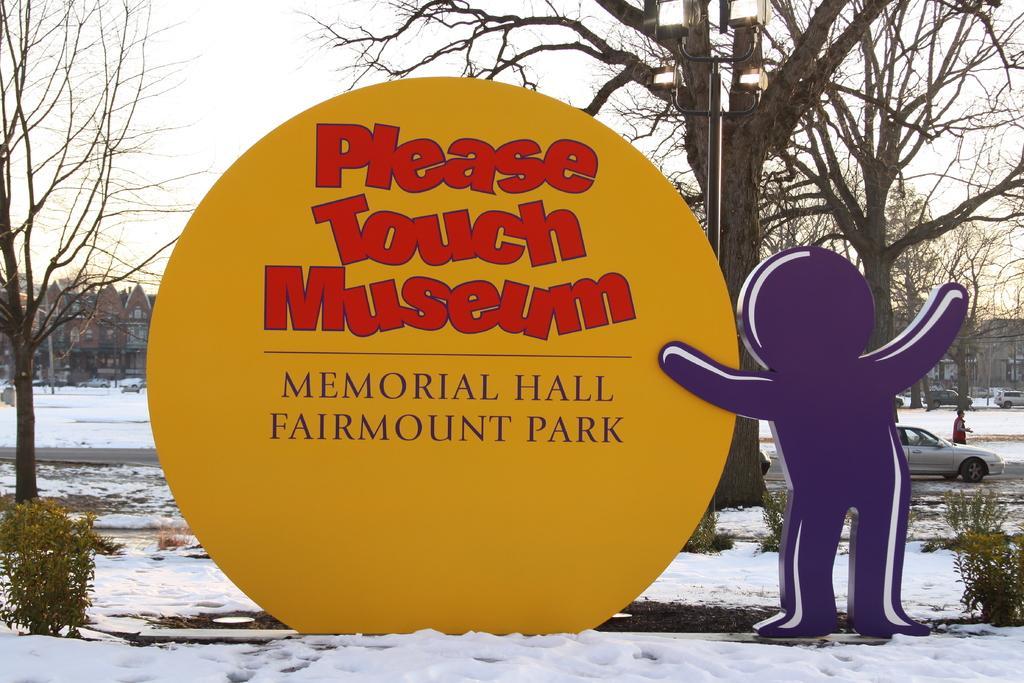In one or two sentences, can you explain what this image depicts? In the picture I can see a yellow color board and I can see the text on it. There is a inflatable balloon structure on the right side. I can see the snow at the bottom of the picture. There are deciduous trees on the left side and the right side as well. I can see the light pole on the side of the road. I can see a car on the road on the right side. In the background, I can see the trees. 